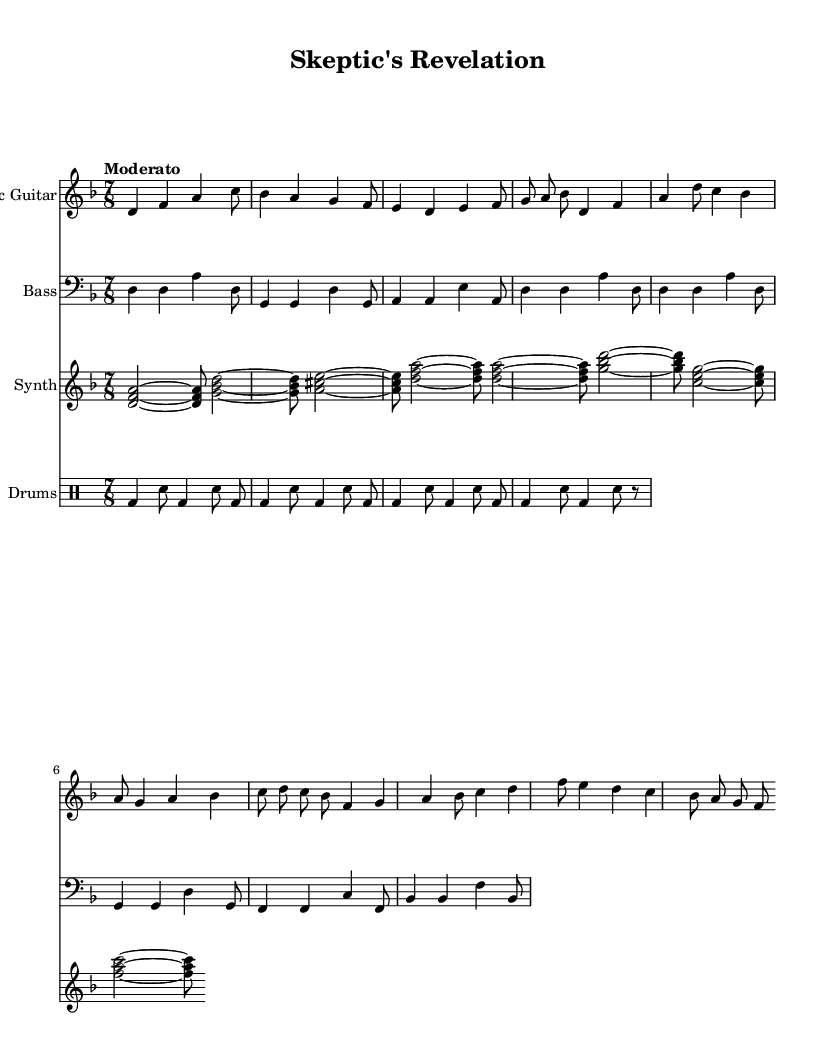What is the key signature of this music? The key signature is D minor, which has one flat (B flat). This can be determined by looking at the key signature indicated at the beginning of the staff.
Answer: D minor What is the time signature of this piece? The time signature is 7/8, indicated at the start of the music. This means there are seven eighth notes in each measure.
Answer: 7/8 What is the tempo marking for this piece? The tempo marking is "Moderato," which suggests a moderate speed. This is noted above the staff in the score.
Answer: Moderato How many measures are in the intro section? The intro section consists of 4 measures, as seen from the grouping of notes before transitioning to the verse.
Answer: 4 Which instruments are included in the score? The score includes Electric Guitar, Bass, Synth, and Drums, indicated by the instrument names at the beginning of each staff.
Answer: Electric Guitar, Bass, Synth, Drums What type of rhythm is primarily used in the drums part? The rhythm in the drums part features a basic pattern of bass drum and snare, commonly found in rock and fusion styles. This can be identified by the sequence of bass (bd) and snare (sn) notations.
Answer: Basic pattern How does the synth part contribute to the overall texture of the music? The synth part provides harmonic support with chords played throughout, enriching the overall sound and blending with the melodic lines. This is evident from the chord notations in the synth staff.
Answer: Harmonic support 